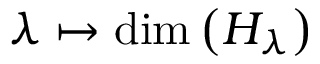<formula> <loc_0><loc_0><loc_500><loc_500>\lambda \mapsto \dim \left ( H _ { \lambda } \right )</formula> 